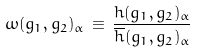<formula> <loc_0><loc_0><loc_500><loc_500>\omega ( g _ { 1 } , g _ { 2 } ) _ { \alpha } \, \equiv \, \frac { h ( g _ { 1 } , g _ { 2 } ) _ { \alpha } } { \overline { h } ( g _ { 1 } , g _ { 2 } ) _ { \alpha } }</formula> 